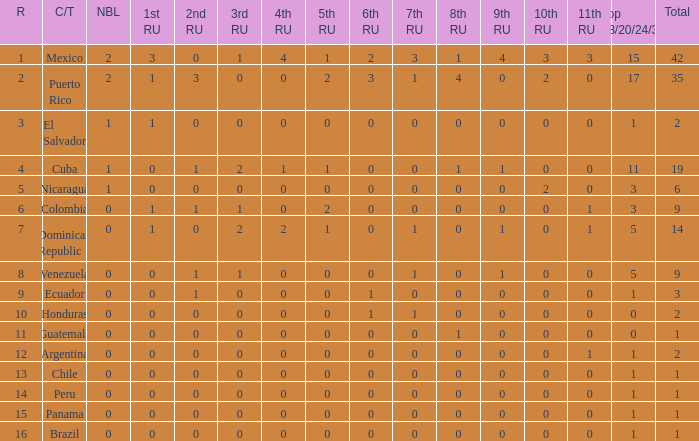What is the 3rd runner-up of the country with more than 0 9th runner-up, an 11th runner-up of 0, and the 1st runner-up greater than 0? None. 